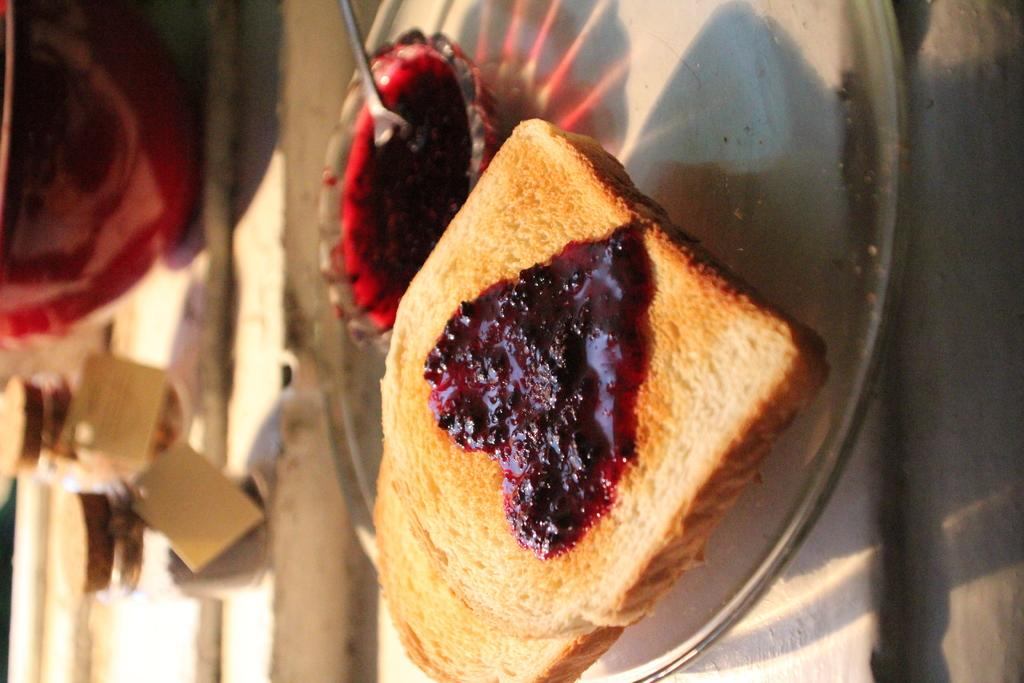What shape is the jam on the bread in the image? The jam on the bread is heart-shaped in the image. What utensil can be seen in the image? There is a spoon in the image. What is contained in the bowl in the image? There is liquid in a bowl in the image. Where are the objects located in the image? The objects are on the left side of the image. How many pizzas are being served by the donkey in the image? There is no donkey or pizza present in the image. 